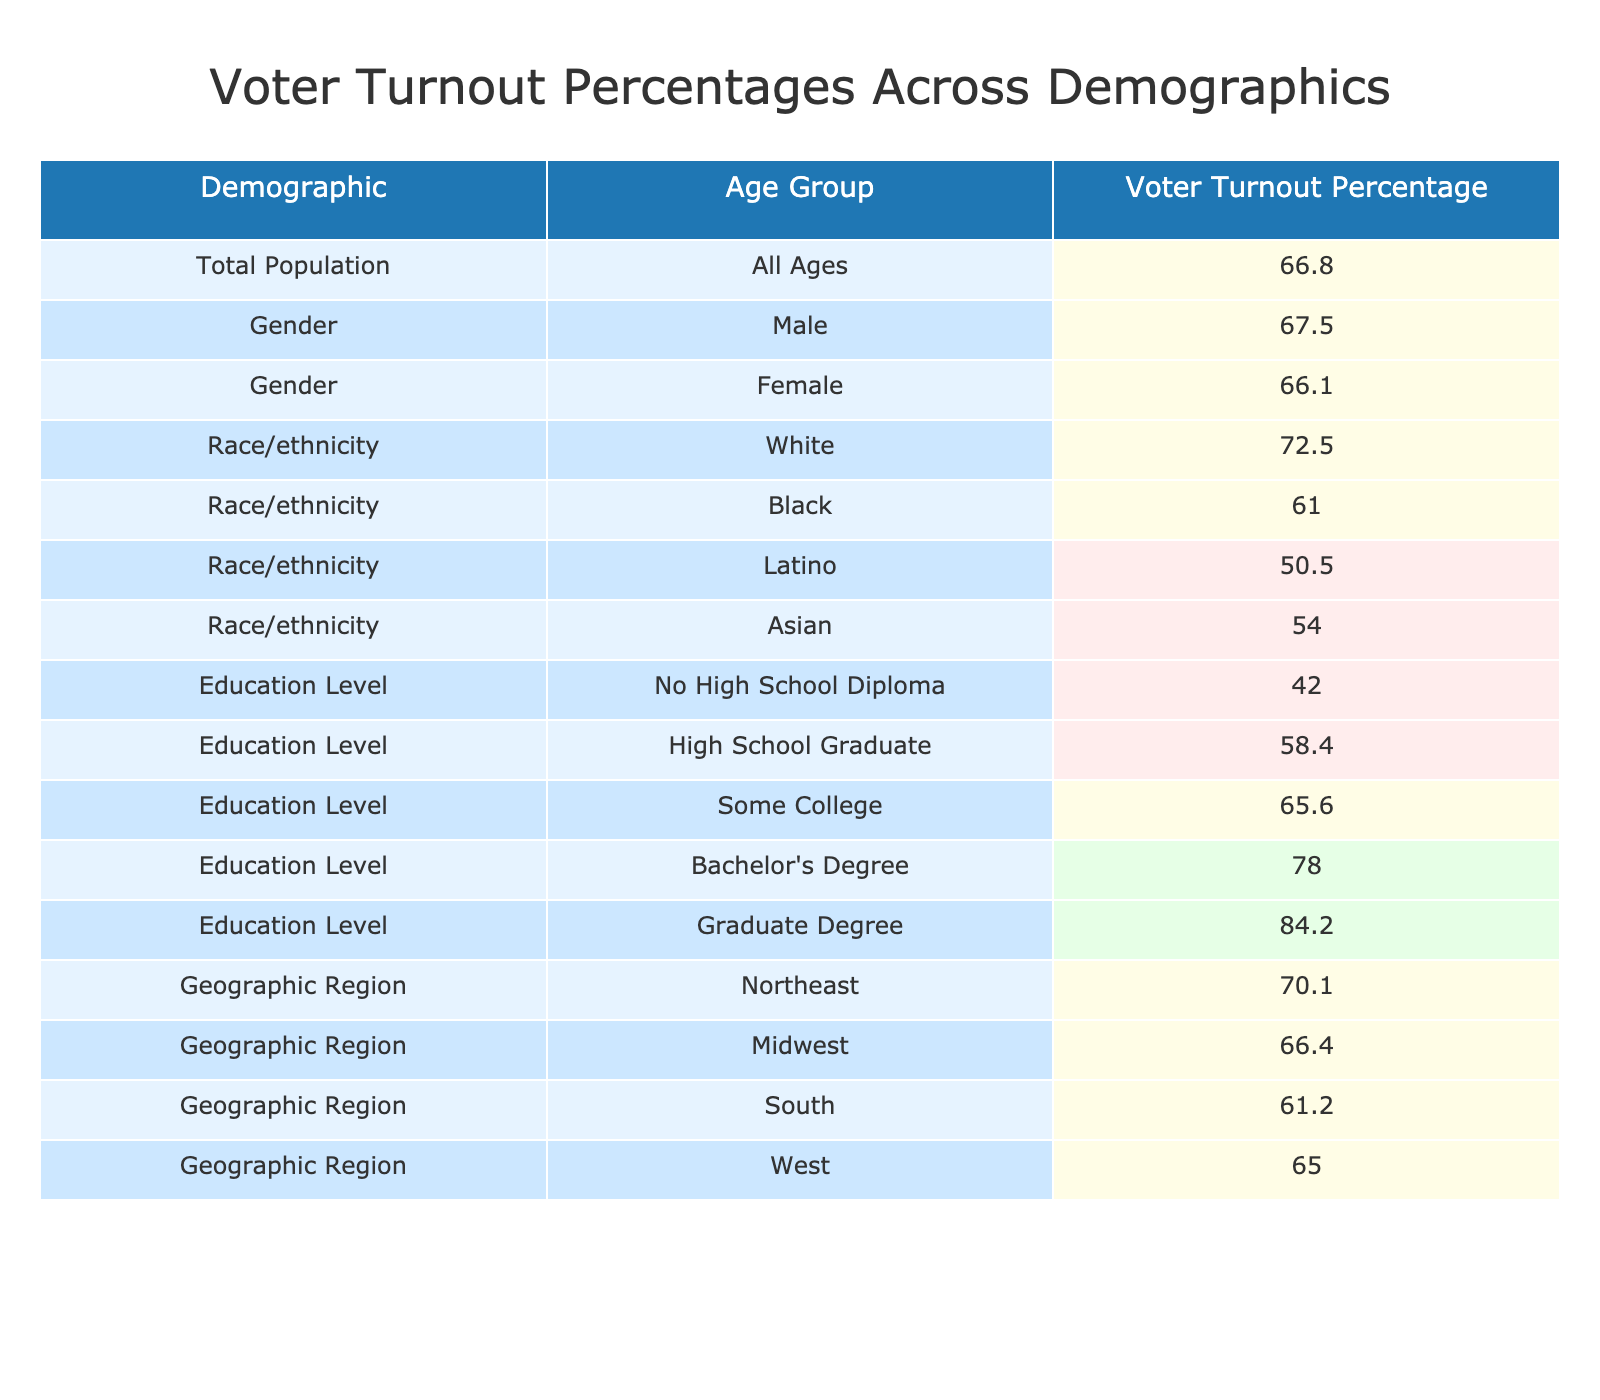What is the overall voter turnout percentage for the total population? The table lists the total population's voter turnout percentage as 66.8%. This value is clearly indicated in the first row of the table.
Answer: 66.8% Which demographic group has the highest voter turnout percentage? The highest percentage is found in the "Graduate Degree" education level, which has a turnout of 84.2%. This is the largest value listed in the table.
Answer: 84.2% Is the voter turnout percentage for Latino individuals below 60%? The table shows that Latino voter turnout is 50.5%, which is indeed below 60%. Therefore, the statement is true.
Answer: Yes What is the difference in voter turnout percentage between males and females? The voter turnout percentage for males is 67.5% and for females is 66.1%. The difference is calculated as 67.5 - 66.1 = 1.4%.
Answer: 1.4% What is the average voter turnout percentage across all educational levels listed in the table? The educational levels and their corresponding percentages are summed up (42.0 + 58.4 + 65.6 + 78.0 + 84.2 = 328.2) and divided by the total of 5 levels, leading to an average of 328.2 / 5 = 65.64%.
Answer: 65.64% Which geographic region has the lowest voter turnout percentage? According to the table, the "South" region has a voter turnout percentage of 61.2%, which is the lowest compared to the other listed regions.
Answer: 61.2% Does the voter turnout for individuals with a high school diploma exceed 60%? The turnout percentage for high school graduates is noted as 58.4%, which does not exceed 60%. This means the statement is false.
Answer: No How do the voter turnout percentages compare between Black and Asian demographics? The voter turnout for Black individuals is 61.0% while for Asian individuals it is 54.0%. The Black demographic has a higher turnout by 7%. This comparison illustrates the difference clearly.
Answer: Black has higher turnout by 7% What percentage of White voters participated in the election compared to the total population? White voters had a turnout of 72.5%, which is higher than the total population turnout of 66.8%. The comparison shows White voters participated more than the general populace.
Answer: Higher than total population What are the voter turnout percentages for individuals with a bachelor's degree and those with no high school diploma? The percentage for individuals with a bachelor's degree is 78.0%, and those with no high school diploma is 42.0%. This highlights the significant educational impact on turnout.
Answer: 78.0% vs 42.0% Can you conclude if voters from the Midwest had a turnout that exceeded the overall average? The Midwest reported a turnout of 66.4%. Comparing this to the overall average of 66.8% indicates that Midwest turnout is slightly below the average. Thus, it's false to say it exceeded the average.
Answer: No 